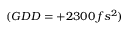<formula> <loc_0><loc_0><loc_500><loc_500>( G D D = + 2 3 0 0 \, f s ^ { 2 } )</formula> 